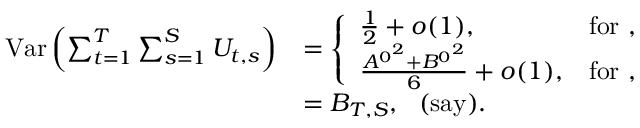Convert formula to latex. <formula><loc_0><loc_0><loc_500><loc_500>\begin{array} { r l } { V a r \left ( \sum _ { t = 1 } ^ { T } \sum _ { s = 1 } ^ { S } U _ { t , s } \right ) } & { = \left \{ \begin{array} { l l } { \frac { 1 } { 2 } + o ( 1 ) , } & { f o r , } \\ { \frac { { A ^ { 0 } } ^ { 2 } + { B ^ { 0 } } ^ { 2 } } { 6 } + o ( 1 ) , } & { f o r , } \end{array} } \\ & { = B _ { T , S } , ( s a y ) . } \end{array}</formula> 